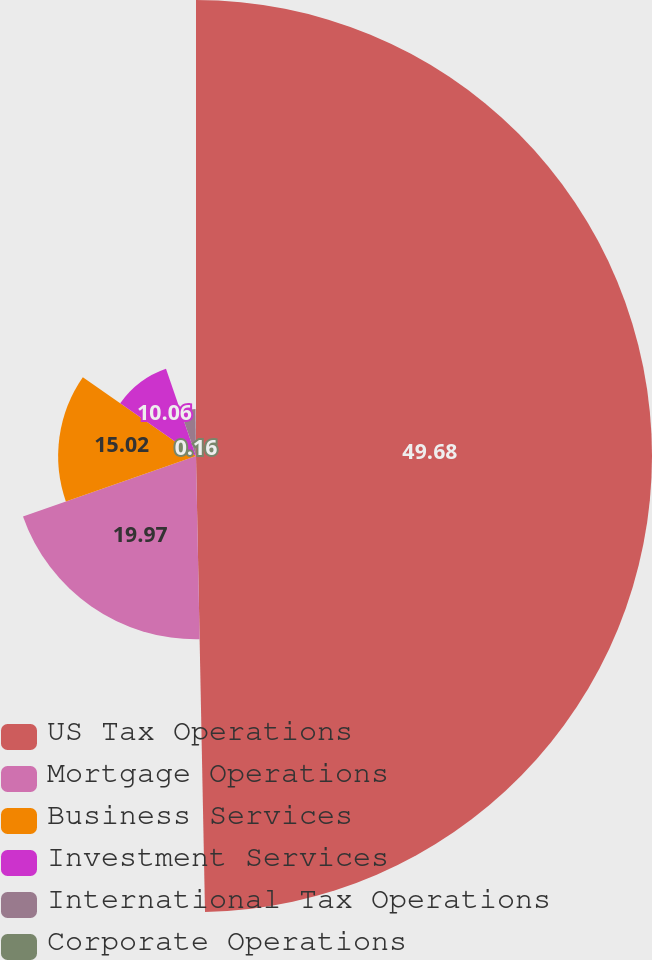Convert chart to OTSL. <chart><loc_0><loc_0><loc_500><loc_500><pie_chart><fcel>US Tax Operations<fcel>Mortgage Operations<fcel>Business Services<fcel>Investment Services<fcel>International Tax Operations<fcel>Corporate Operations<nl><fcel>49.69%<fcel>19.97%<fcel>15.02%<fcel>10.06%<fcel>5.11%<fcel>0.16%<nl></chart> 